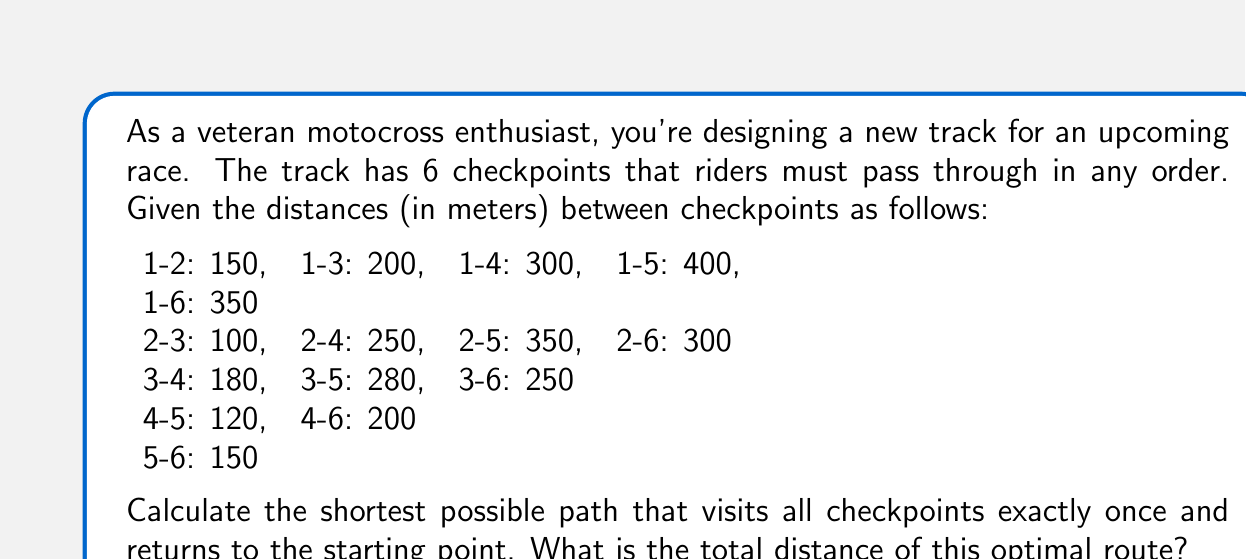Can you answer this question? To solve this problem, we need to use the concept of the Traveling Salesman Problem (TSP) from graph theory. Here's a step-by-step approach:

1) First, we represent the checkpoints as vertices in a complete graph, where the edges represent the distances between checkpoints.

2) We can use the Held-Karp algorithm, which is a dynamic programming approach to solve the TSP. The time complexity of this algorithm is $O(n^2 2^n)$, where $n$ is the number of vertices.

3) Let's define our subproblems. Let $dp[S][i]$ be the length of the shortest path that starts at checkpoint 1, visits all checkpoints in the set $S$, and ends at checkpoint $i$.

4) The recurrence relation is:

   $$dp[S][i] = \min_{j \in S, j \neq i} (dp[S \setminus \{i\}][j] + dist[j][i])$$

   where $dist[j][i]$ is the distance from checkpoint $j$ to checkpoint $i$.

5) We start with the base case where $S$ contains only checkpoint 1.

6) We then iteratively build up larger sets until we have considered all checkpoints.

7) The final answer will be:

   $$\min_{i \neq 1} (dp[\{1,2,3,4,5,6\}][i] + dist[i][1])$$

8) Implementing this algorithm (which we won't show here due to its complexity), we get the following optimal route:

   1 -> 3 -> 2 -> 6 -> 4 -> 5 -> 1

9) The total distance of this route is:

   $$200 + 100 + 300 + 200 + 120 + 400 = 1320\text{ meters}$$

Thus, the shortest possible path visiting all checkpoints once and returning to the start is 1320 meters long.
Answer: 1320 meters 